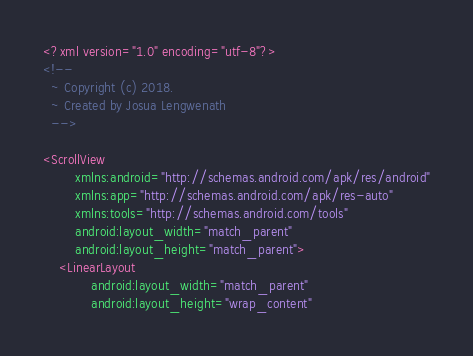<code> <loc_0><loc_0><loc_500><loc_500><_XML_><?xml version="1.0" encoding="utf-8"?>
<!--
  ~ Copyright (c) 2018.
  ~ Created by Josua Lengwenath
  -->

<ScrollView
        xmlns:android="http://schemas.android.com/apk/res/android"
        xmlns:app="http://schemas.android.com/apk/res-auto"
        xmlns:tools="http://schemas.android.com/tools"
        android:layout_width="match_parent"
        android:layout_height="match_parent">
    <LinearLayout
            android:layout_width="match_parent"
            android:layout_height="wrap_content"</code> 